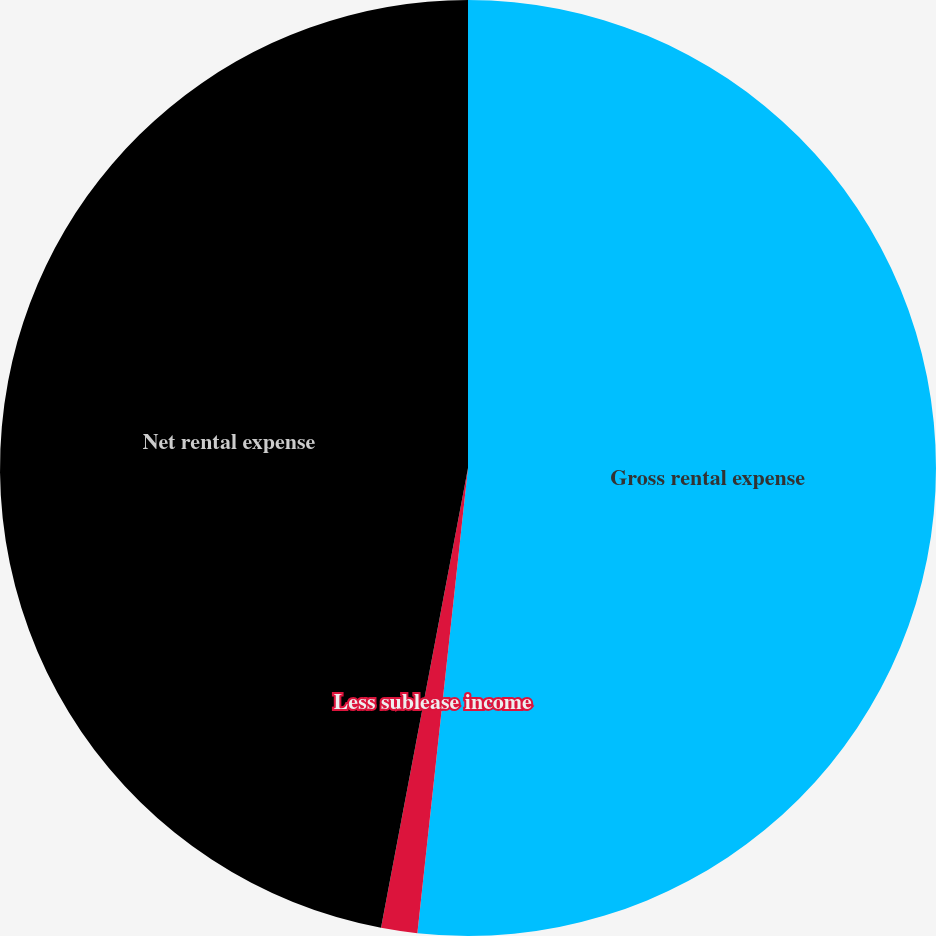<chart> <loc_0><loc_0><loc_500><loc_500><pie_chart><fcel>Gross rental expense<fcel>Less sublease income<fcel>Net rental expense<nl><fcel>51.72%<fcel>1.25%<fcel>47.02%<nl></chart> 